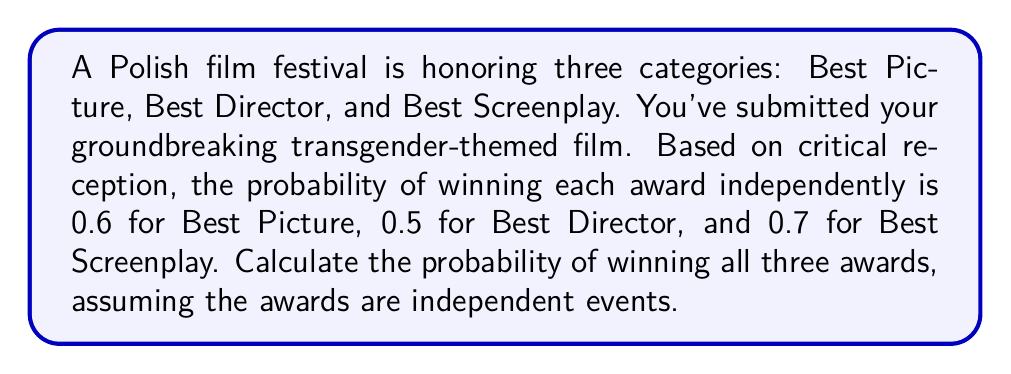Show me your answer to this math problem. To solve this problem, we'll use the concept of joint probability for independent events. When events are independent, the probability of all events occurring simultaneously is the product of their individual probabilities.

Let's define our events:
$A$: Winning Best Picture (P(A) = 0.6)
$B$: Winning Best Director (P(B) = 0.5)
$C$: Winning Best Screenplay (P(C) = 0.7)

We want to find P(A ∩ B ∩ C), the probability of all three events occurring.

For independent events:
$$P(A \cap B \cap C) = P(A) \cdot P(B) \cdot P(C)$$

Substituting the given probabilities:

$$P(A \cap B \cap C) = 0.6 \cdot 0.5 \cdot 0.7$$

Calculating:
$$P(A \cap B \cap C) = 0.21$$

Therefore, the probability of winning all three awards is 0.21 or 21%.
Answer: 0.21 